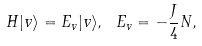<formula> <loc_0><loc_0><loc_500><loc_500>H | v \rangle = E _ { v } | v \rangle , \ E _ { v } = - \frac { J } { 4 } N ,</formula> 